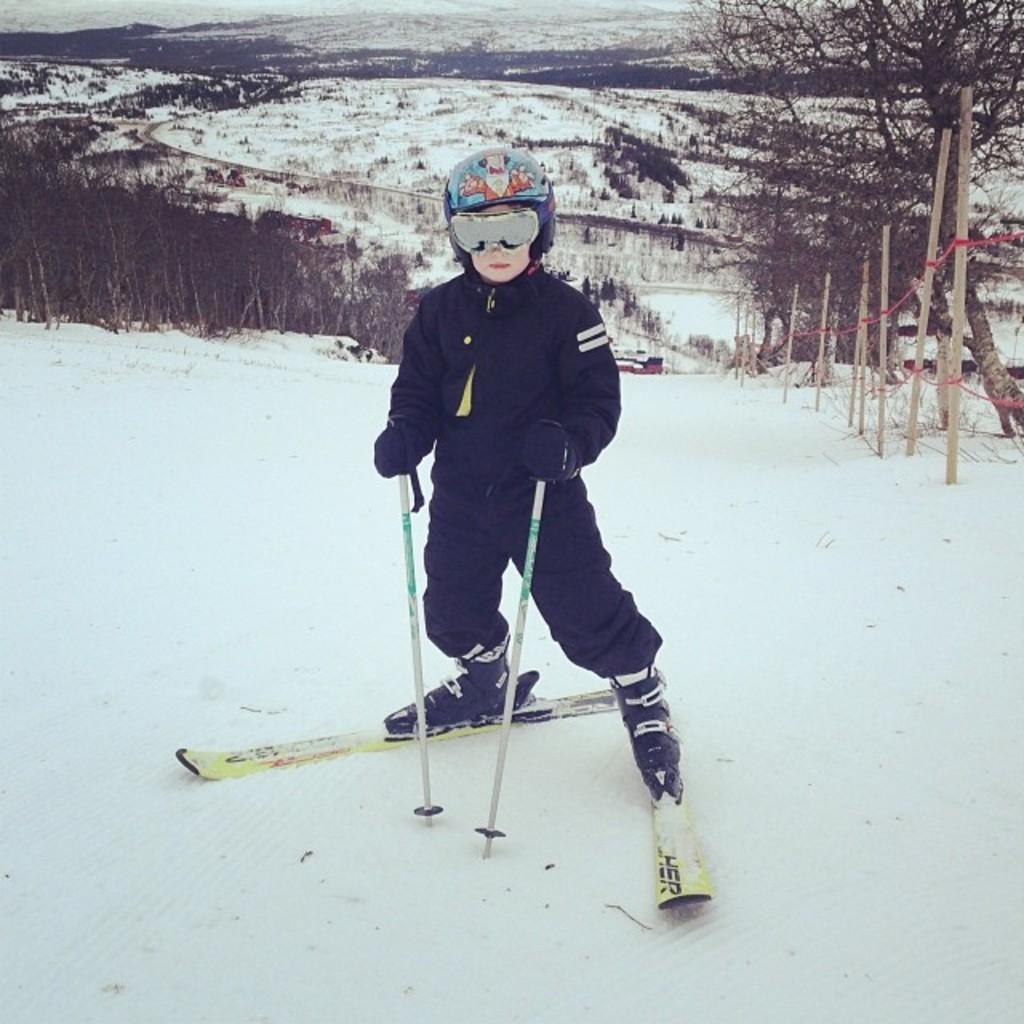What activity is the person in the image engaged in? There is a person skiing in the image. On what surface is the person skiing? The person is skiing on the snow. What can be seen in the background of the image? There are trees visible on the side in the image. What type of quiver can be seen attached to the person's back in the image? There is no quiver present in the image; the person is skiing, not using a bow and arrow. What type of bottle is the person holding in their hand in the image? There is no bottle present in the image; the person is skiing and does not have any visible objects in their hands. 